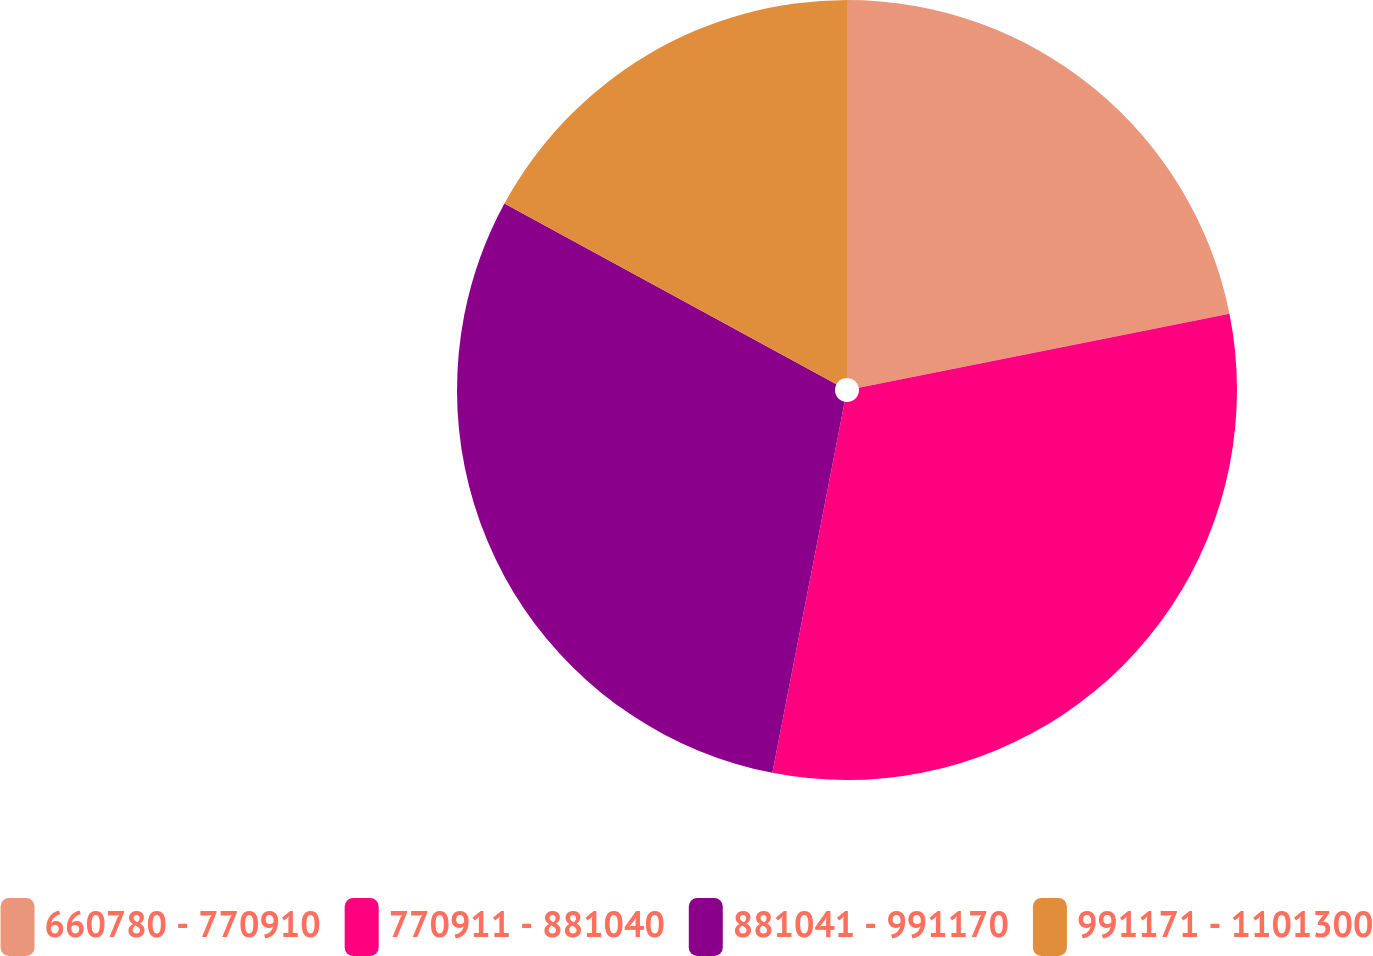Convert chart to OTSL. <chart><loc_0><loc_0><loc_500><loc_500><pie_chart><fcel>660780 - 770910<fcel>770911 - 881040<fcel>881041 - 991170<fcel>991171 - 1101300<nl><fcel>21.87%<fcel>31.2%<fcel>29.87%<fcel>17.07%<nl></chart> 